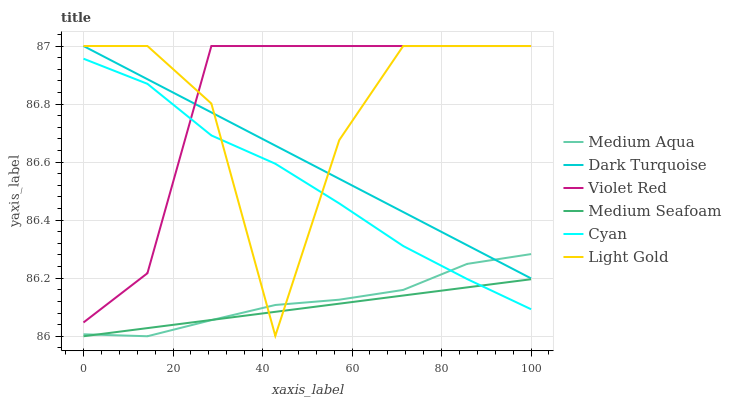Does Medium Seafoam have the minimum area under the curve?
Answer yes or no. Yes. Does Violet Red have the maximum area under the curve?
Answer yes or no. Yes. Does Dark Turquoise have the minimum area under the curve?
Answer yes or no. No. Does Dark Turquoise have the maximum area under the curve?
Answer yes or no. No. Is Medium Seafoam the smoothest?
Answer yes or no. Yes. Is Light Gold the roughest?
Answer yes or no. Yes. Is Dark Turquoise the smoothest?
Answer yes or no. No. Is Dark Turquoise the roughest?
Answer yes or no. No. Does Dark Turquoise have the lowest value?
Answer yes or no. No. Does Medium Aqua have the highest value?
Answer yes or no. No. Is Cyan less than Dark Turquoise?
Answer yes or no. Yes. Is Violet Red greater than Medium Aqua?
Answer yes or no. Yes. Does Cyan intersect Dark Turquoise?
Answer yes or no. No. 